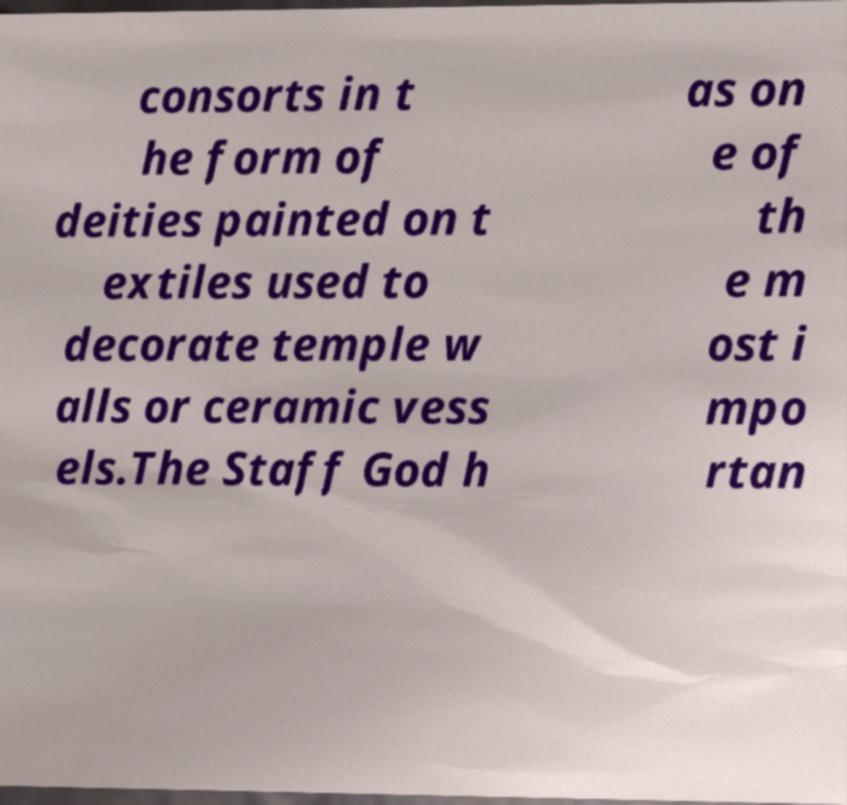Please identify and transcribe the text found in this image. consorts in t he form of deities painted on t extiles used to decorate temple w alls or ceramic vess els.The Staff God h as on e of th e m ost i mpo rtan 